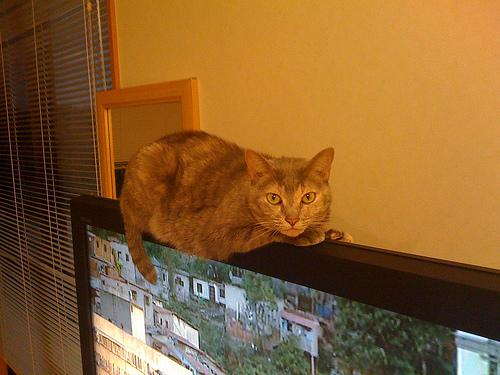How does the cat's interaction with the television affect the image sentiment? The cat being not in a good mood while lying on top of the television adds a sense of tension or unease to the image. How is the cat's mood depicted in the picture? The cat seems to be not in a good mood as it sits on the television, staring at someone. Describe the appearance of the television screen in the image. The television is turned on, with the frame being black, and showing images of gray houses and a tree. Identify the primary object in the image and their current activity. A cat with gray and white fur is lying on top of a television, appearing to stare at someone. Can you identify any distinct features of the cat, such as its tail or eyes? The cat has a striped tail and is awake with alert eyes. Is the cat sitting on the blue couch? No, it's not mentioned in the image. Write a fancy caption for the image that describes the cat's action. Regal feline resting paws on television, enthralled by its surroundings. How are the cat's eyes described in the image? The cat has golden eyes. Describe the cat's mood in the image using an adjective. Not in good mood Which object is hanging on the wall in the image? A mirror Describe the setting where the cat is resting in the image. The cat is resting on top of the television against a yellow wall with a mirror, a picture frame, and a window with blinds. What details can be observed about the handle of the blinds pull string and wall color? The handle is on the left side and the wall is yellow. Is the cat staring at the open window? The cat is described as staring at someone, and the window is described as being closed and covered by blinds, which makes it unlikely that the cat is staring at the window. What can be observed about the window near the picture frame? The window is closed and has Venetian blinds on it. What is covering the window in the image? White blinds What activity is the cat engaging in on top of the television? The cat is resting its chin on its paw. Choose the correct description of the cat: a) orange cat perched on ledge, b) gray and white cat lying on top of the flat-screen TV, or c) small kitten playing with a toy. b) Gray and white cat lying on top of the flat-screen TV Describe the shape of the cat's ears in the image. The cat has two pointy ears. What is the wall's color and condition in the image? The wall is painted yellow with no wallpaper. Which statements describe the cat in the image?  The cat is gray and white, has two ears, is staring at someone, its tail is striped, is not in a good mood, and is awake. Identify the position of the cat in relation to the television. The cat is lying on top of the television. Can you see the purple wallpaper on the wall? There's no mention of purple wallpaper in the image. The wall is described as yellow and without wallpaper. List the colors visible on the television in the image. Gray houses, tree, old white buildings crowded together. Create a brief story about the cat and its interaction with the television. Once upon a time in a cozy living room, a curious cat named Whiskers found comfort on top of the television. With golden eyes, Whiskers intently watched the screen, captivated by the moving images. What can be inferred about the current event taking place in the image? The cat is lying on the TV while it's turned on, in a room with a yellow wall, a window with blinds, and a mirror on the wall. What is the color of the television frame and what device is it showing? The frame is black and it is showing a big screen TV. Provide a brief description of the cat's tail. The tail is striped and hanging down on the TV screen. 